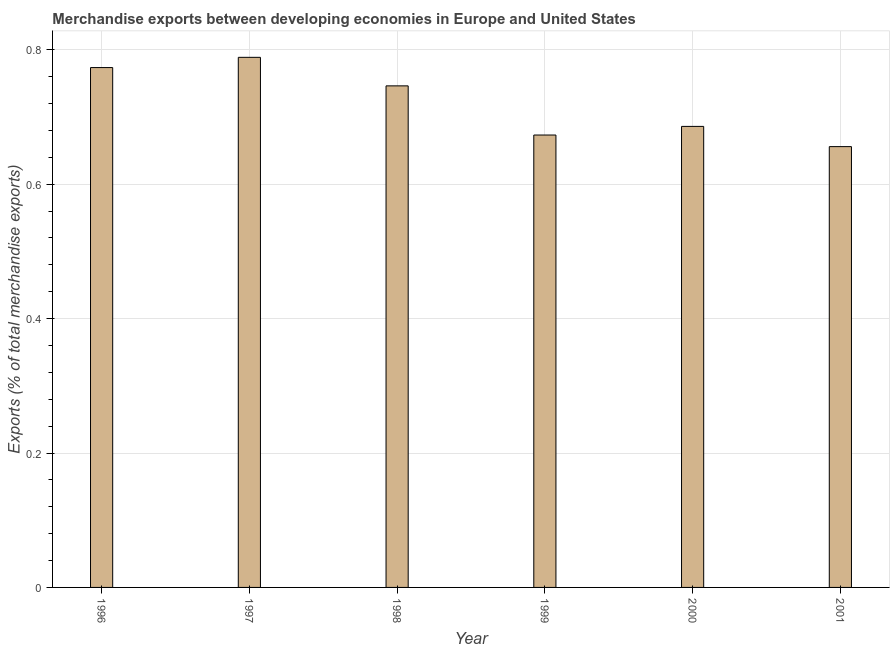Does the graph contain any zero values?
Provide a succinct answer. No. Does the graph contain grids?
Make the answer very short. Yes. What is the title of the graph?
Offer a very short reply. Merchandise exports between developing economies in Europe and United States. What is the label or title of the Y-axis?
Give a very brief answer. Exports (% of total merchandise exports). What is the merchandise exports in 2000?
Keep it short and to the point. 0.69. Across all years, what is the maximum merchandise exports?
Make the answer very short. 0.79. Across all years, what is the minimum merchandise exports?
Provide a short and direct response. 0.66. In which year was the merchandise exports maximum?
Your answer should be compact. 1997. In which year was the merchandise exports minimum?
Provide a succinct answer. 2001. What is the sum of the merchandise exports?
Ensure brevity in your answer.  4.32. What is the difference between the merchandise exports in 1999 and 2001?
Your answer should be very brief. 0.02. What is the average merchandise exports per year?
Provide a short and direct response. 0.72. What is the median merchandise exports?
Your answer should be very brief. 0.72. In how many years, is the merchandise exports greater than 0.28 %?
Give a very brief answer. 6. Do a majority of the years between 1998 and 2001 (inclusive) have merchandise exports greater than 0.16 %?
Offer a very short reply. Yes. What is the ratio of the merchandise exports in 1996 to that in 2001?
Ensure brevity in your answer.  1.18. Is the merchandise exports in 1997 less than that in 2001?
Your response must be concise. No. Is the difference between the merchandise exports in 1996 and 2001 greater than the difference between any two years?
Provide a succinct answer. No. What is the difference between the highest and the second highest merchandise exports?
Ensure brevity in your answer.  0.01. What is the difference between the highest and the lowest merchandise exports?
Offer a terse response. 0.13. How many bars are there?
Offer a terse response. 6. Are all the bars in the graph horizontal?
Keep it short and to the point. No. What is the Exports (% of total merchandise exports) of 1996?
Your answer should be very brief. 0.77. What is the Exports (% of total merchandise exports) of 1997?
Keep it short and to the point. 0.79. What is the Exports (% of total merchandise exports) of 1998?
Offer a very short reply. 0.75. What is the Exports (% of total merchandise exports) in 1999?
Give a very brief answer. 0.67. What is the Exports (% of total merchandise exports) of 2000?
Ensure brevity in your answer.  0.69. What is the Exports (% of total merchandise exports) in 2001?
Provide a short and direct response. 0.66. What is the difference between the Exports (% of total merchandise exports) in 1996 and 1997?
Ensure brevity in your answer.  -0.02. What is the difference between the Exports (% of total merchandise exports) in 1996 and 1998?
Your answer should be compact. 0.03. What is the difference between the Exports (% of total merchandise exports) in 1996 and 1999?
Keep it short and to the point. 0.1. What is the difference between the Exports (% of total merchandise exports) in 1996 and 2000?
Ensure brevity in your answer.  0.09. What is the difference between the Exports (% of total merchandise exports) in 1996 and 2001?
Your response must be concise. 0.12. What is the difference between the Exports (% of total merchandise exports) in 1997 and 1998?
Keep it short and to the point. 0.04. What is the difference between the Exports (% of total merchandise exports) in 1997 and 1999?
Provide a succinct answer. 0.12. What is the difference between the Exports (% of total merchandise exports) in 1997 and 2000?
Make the answer very short. 0.1. What is the difference between the Exports (% of total merchandise exports) in 1997 and 2001?
Your response must be concise. 0.13. What is the difference between the Exports (% of total merchandise exports) in 1998 and 1999?
Make the answer very short. 0.07. What is the difference between the Exports (% of total merchandise exports) in 1998 and 2000?
Your response must be concise. 0.06. What is the difference between the Exports (% of total merchandise exports) in 1998 and 2001?
Offer a very short reply. 0.09. What is the difference between the Exports (% of total merchandise exports) in 1999 and 2000?
Offer a very short reply. -0.01. What is the difference between the Exports (% of total merchandise exports) in 1999 and 2001?
Give a very brief answer. 0.02. What is the difference between the Exports (% of total merchandise exports) in 2000 and 2001?
Keep it short and to the point. 0.03. What is the ratio of the Exports (% of total merchandise exports) in 1996 to that in 1997?
Keep it short and to the point. 0.98. What is the ratio of the Exports (% of total merchandise exports) in 1996 to that in 1998?
Offer a terse response. 1.04. What is the ratio of the Exports (% of total merchandise exports) in 1996 to that in 1999?
Make the answer very short. 1.15. What is the ratio of the Exports (% of total merchandise exports) in 1996 to that in 2000?
Provide a short and direct response. 1.13. What is the ratio of the Exports (% of total merchandise exports) in 1996 to that in 2001?
Your answer should be very brief. 1.18. What is the ratio of the Exports (% of total merchandise exports) in 1997 to that in 1998?
Your answer should be very brief. 1.06. What is the ratio of the Exports (% of total merchandise exports) in 1997 to that in 1999?
Ensure brevity in your answer.  1.17. What is the ratio of the Exports (% of total merchandise exports) in 1997 to that in 2000?
Give a very brief answer. 1.15. What is the ratio of the Exports (% of total merchandise exports) in 1997 to that in 2001?
Offer a very short reply. 1.2. What is the ratio of the Exports (% of total merchandise exports) in 1998 to that in 1999?
Ensure brevity in your answer.  1.11. What is the ratio of the Exports (% of total merchandise exports) in 1998 to that in 2000?
Offer a very short reply. 1.09. What is the ratio of the Exports (% of total merchandise exports) in 1998 to that in 2001?
Make the answer very short. 1.14. What is the ratio of the Exports (% of total merchandise exports) in 1999 to that in 2001?
Provide a succinct answer. 1.03. What is the ratio of the Exports (% of total merchandise exports) in 2000 to that in 2001?
Keep it short and to the point. 1.05. 